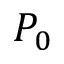Convert formula to latex. <formula><loc_0><loc_0><loc_500><loc_500>P _ { 0 }</formula> 